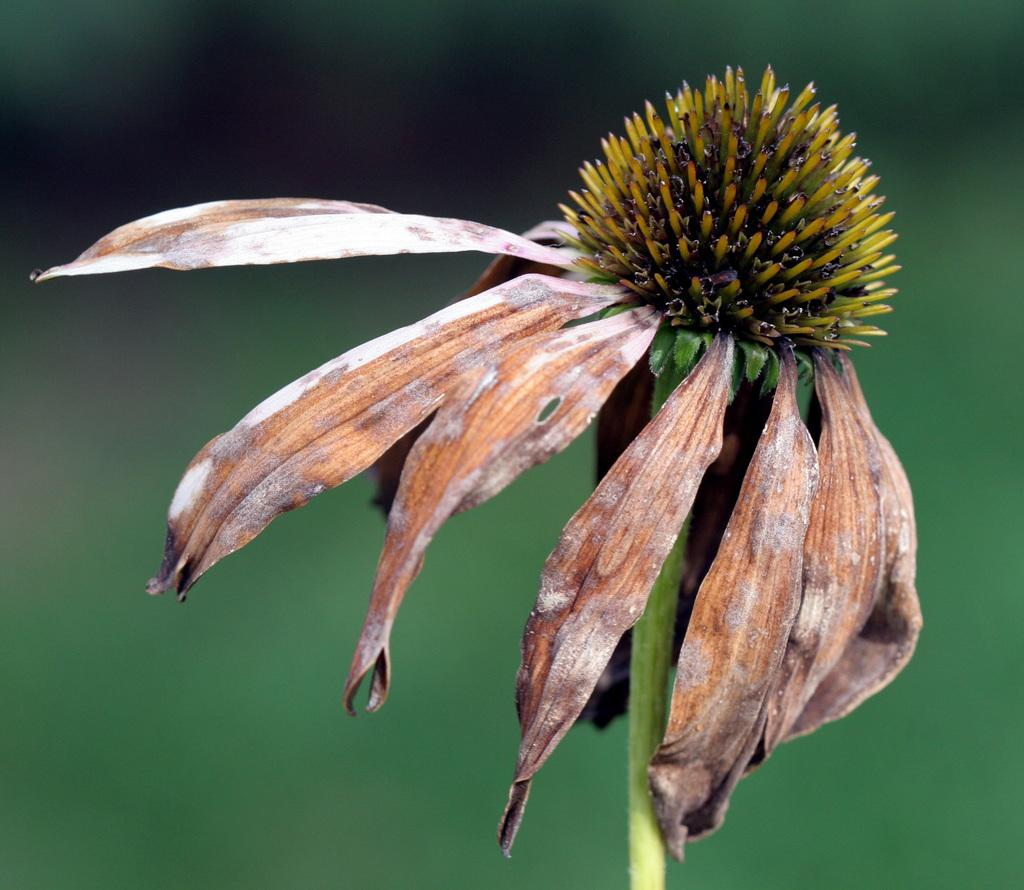What is the main subject of the image? There is a flower in the image. What is the condition of the flower's petals? The flower has dried petals. How would you describe the background of the image? The background of the image is blurry. Where is the faucet located in the image? There is no faucet present in the image. What class is the flower representing in the image? The image does not depict the flower as representing any class. 